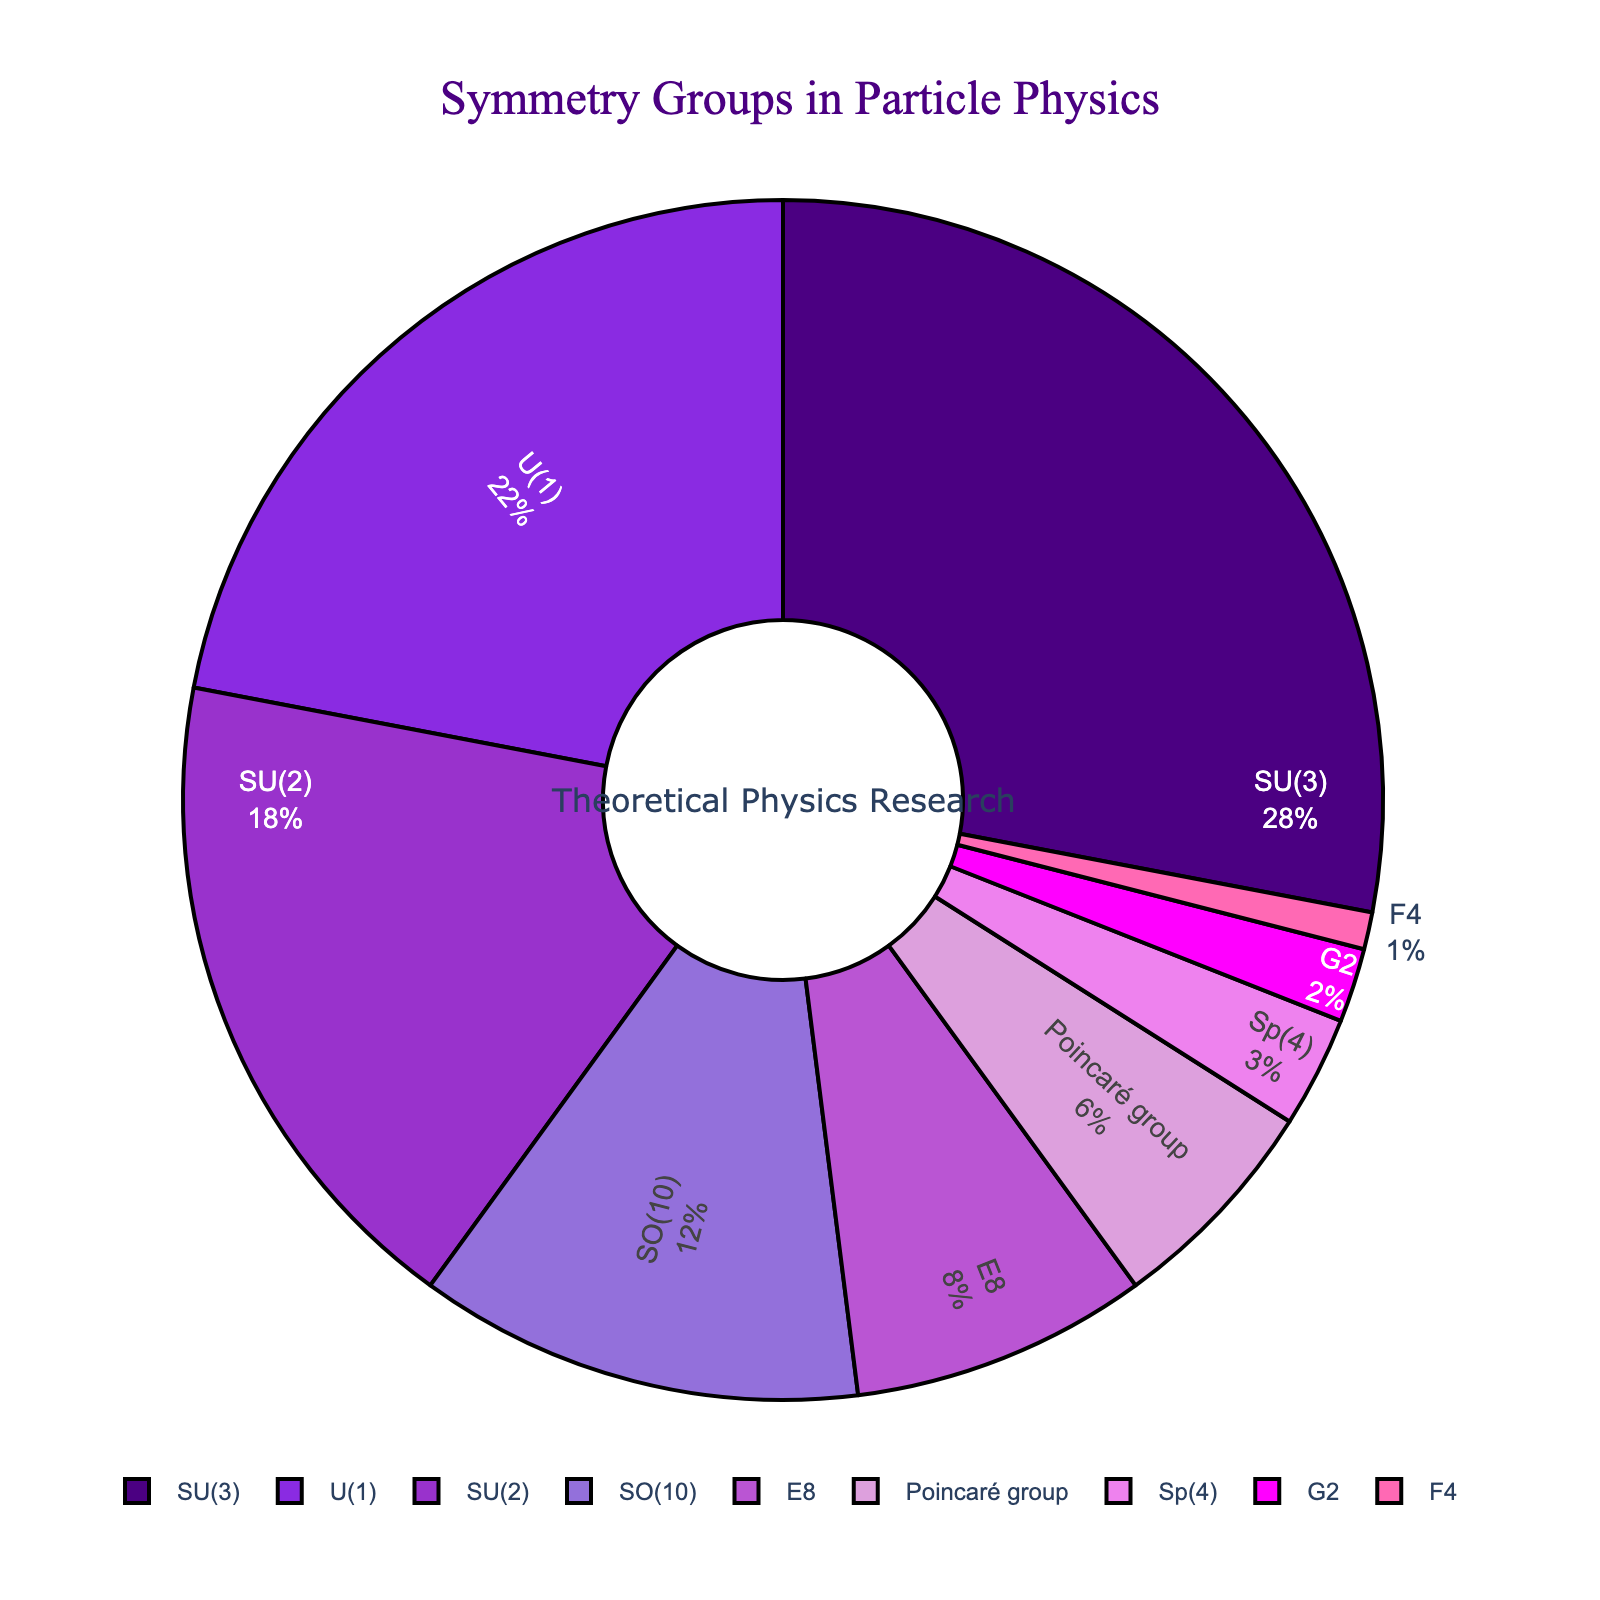Which symmetry group has the largest percentage? The pie chart displays multiple symmetry groups with their corresponding percentages. By visually assessing the segments of the chart, SU(3) has the largest portion, indicating it has the largest percentage.
Answer: SU(3) Which symmetry group accounts for the smallest percentage? The pie chart includes various sized segments with the smallest segment representing the group with the least percentage. By visual inspection, F4 has the smallest segment.
Answer: F4 What is the combined percentage of SU(2) and SO(10)? To find the combined percentage, sum the individual percentages of SU(2) and SO(10). SU(2) has 18% and SO(10) has 12%. Adding these together gives 18 + 12 = 30%.
Answer: 30% Which symmetry groups have percentages greater than 20%? The pie chart highlights each symmetry group with their percentages. By visual evaluation, SU(3) and U(1) have percentages above 20%.
Answer: SU(3), U(1) What is the difference in percentage between E8 and the Poincaré group? To find the difference, subtract the percentage of the Poincaré group (6%) from E8 (8%). This gives 8 - 6 = 2%.
Answer: 2% Between Sp(4) and G2, which group has a larger percentage and by how much? Compare the segments representing Sp(4) and G2 in the pie chart. Sp(4) has 3% while G2 has 2%. The difference is 3 - 2 = 1%.
Answer: Sp(4 by 1%) What is the average percentage of U(1), SU(2), and SO(10)? To find the average, sum the percentages of U(1) (22%), SU(2) (18%), and SO(10) (12%), then divide by the number of groups. (22 + 18 + 12) / 3 = 52 / 3 ≈ 17.33%.
Answer: 17.33% How many symmetry groups have a percentage less than 10%? Identify the segments corresponding to percentages below 10%: E8 (8%), Poincaré group (6%), Sp(4) (3%), G2 (2%), and F4 (1%). There are 5 such groups.
Answer: 5 Which symmetry group is represented by a color closest to purple? The colors in the pie chart represent different symmetry groups. The segment for SU(3), the largest percentage, is closest to purple.
Answer: SU(3) What is the total percentage accounted for by G2, F4, and Sp(4)? Sum the percentages of G2 (2%), F4 (1%), and Sp(4) (3%). This yields 2 + 1 + 3 = 6%.
Answer: 6% 